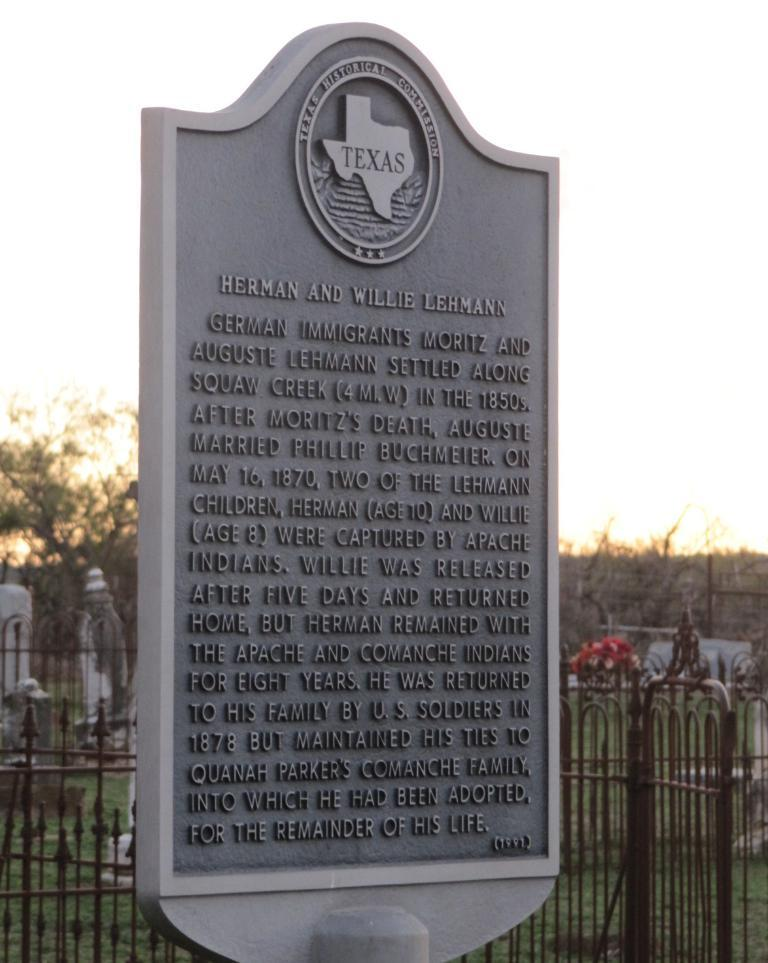What is the main subject of the image? There is a memorial in the image. What can be found on the memorial? There is text on the memorial. What type of barrier is present in the image? There is a fence in the image. What type of vegetation is visible in the image? There is grass and a tree in the image. What is visible in the background of the image? The sky is visible in the image. How many clocks are hanging from the tree in the image? There are no clocks hanging from the tree in the image. What color is the eye of the person depicted on the memorial? There is no person depicted on the memorial, and therefore no eye to describe. 